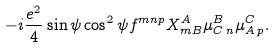<formula> <loc_0><loc_0><loc_500><loc_500>- i \frac { e ^ { 2 } } { 4 } \sin \psi \cos ^ { 2 } \psi f ^ { m n p } X ^ { A } _ { m B } \mu ^ { B } _ { C \, n } \mu ^ { C } _ { A \, p } .</formula> 